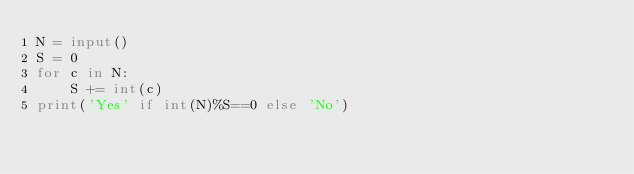<code> <loc_0><loc_0><loc_500><loc_500><_Python_>N = input()
S = 0
for c in N:
    S += int(c)
print('Yes' if int(N)%S==0 else 'No')</code> 